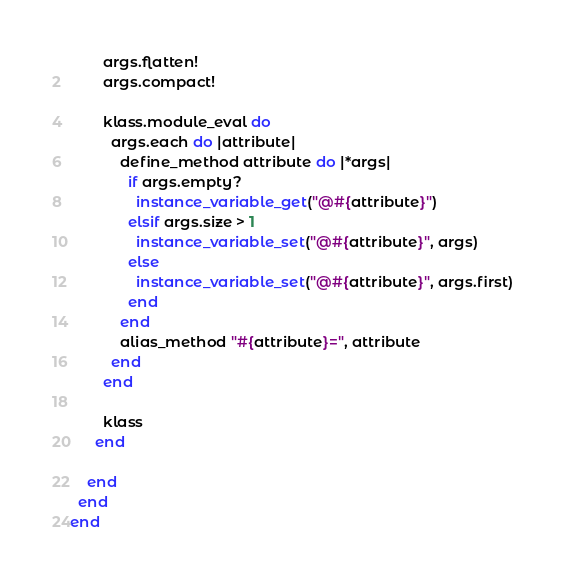Convert code to text. <code><loc_0><loc_0><loc_500><loc_500><_Ruby_>
        args.flatten!
        args.compact!

        klass.module_eval do
          args.each do |attribute|
            define_method attribute do |*args|
              if args.empty?
                instance_variable_get("@#{attribute}")
              elsif args.size > 1
                instance_variable_set("@#{attribute}", args)
              else
                instance_variable_set("@#{attribute}", args.first)
              end
            end
            alias_method "#{attribute}=", attribute
          end
        end

        klass
      end

    end
  end
end
</code> 